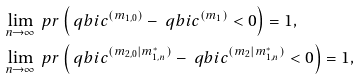<formula> <loc_0><loc_0><loc_500><loc_500>& \lim _ { n \to \infty } \ p r \left ( \ q b i c ^ { ( m _ { 1 , 0 } ) } - \ q b i c ^ { ( m _ { 1 } ) } < 0 \right ) = 1 , \\ & \lim _ { n \to \infty } \ p r \left ( \ q b i c ^ { ( m _ { 2 , 0 } | m _ { 1 , n } ^ { \ast } ) } - \ q b i c ^ { ( m _ { 2 } | m _ { 1 , n } ^ { \ast } ) } < 0 \right ) = 1 ,</formula> 